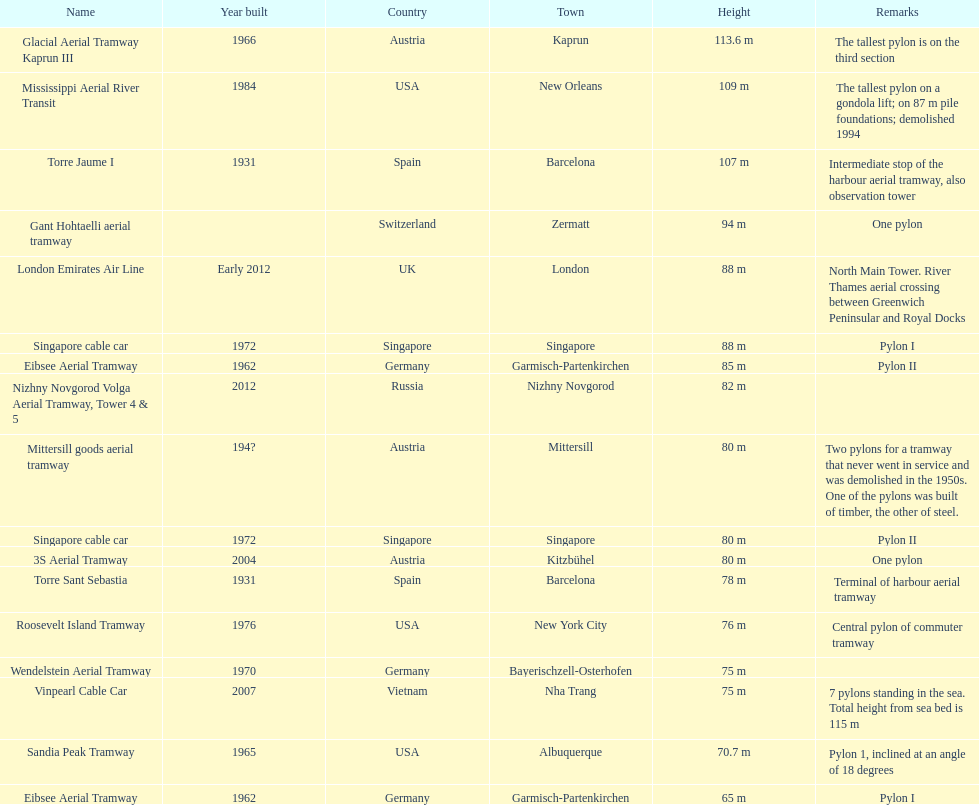The height of the london emirates air line pylon is equivalent to which other pylon? Singapore cable car. 